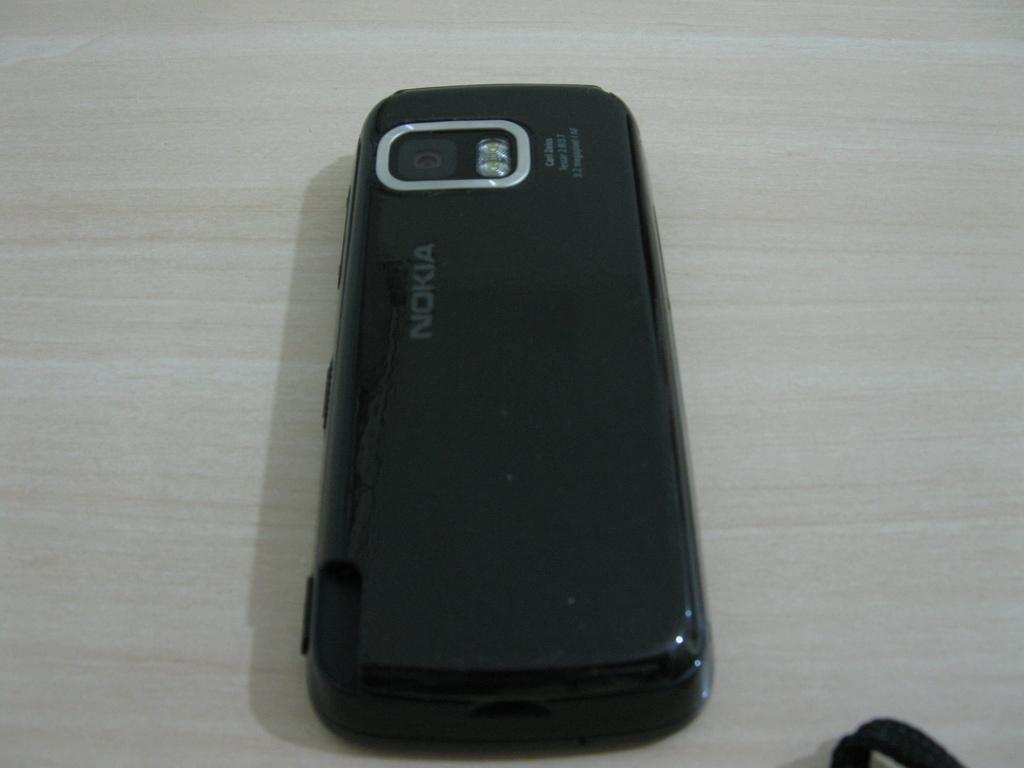<image>
Create a compact narrative representing the image presented. a phone with the word Nokia at the top of it 